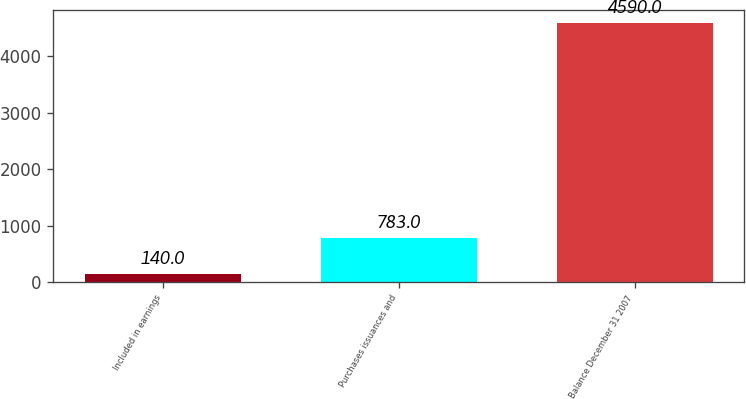Convert chart. <chart><loc_0><loc_0><loc_500><loc_500><bar_chart><fcel>Included in earnings<fcel>Purchases issuances and<fcel>Balance December 31 2007<nl><fcel>140<fcel>783<fcel>4590<nl></chart> 